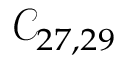<formula> <loc_0><loc_0><loc_500><loc_500>\mathcal { C } _ { 2 7 , 2 9 }</formula> 